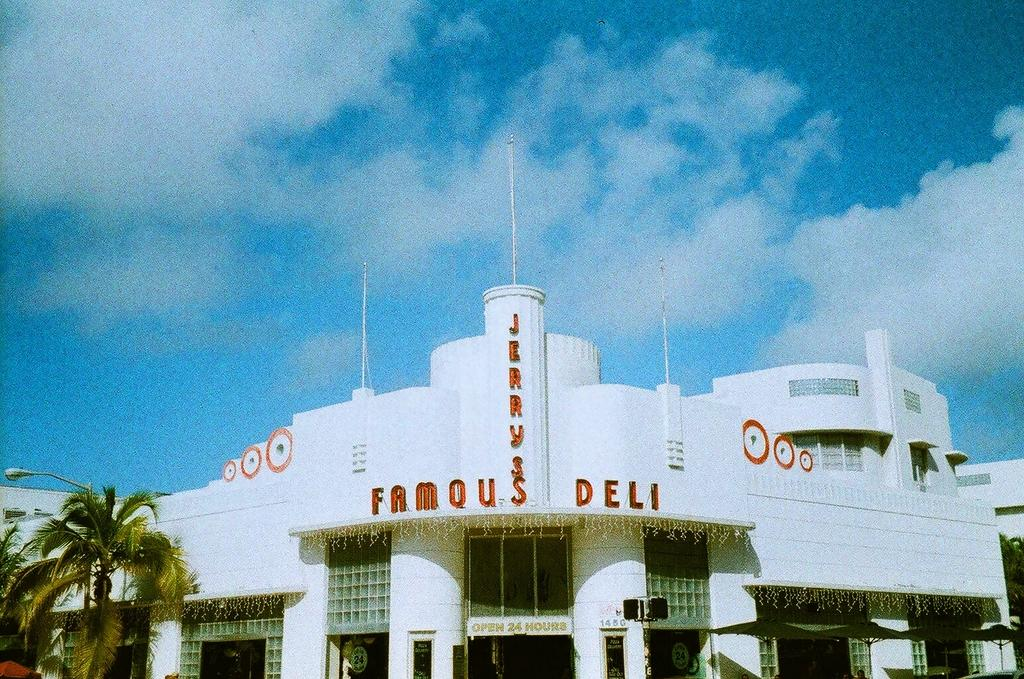<image>
Create a compact narrative representing the image presented. Jerry's Famous Deli has a palm tree in front of it. 